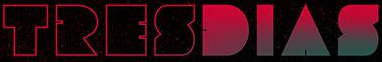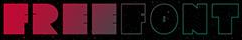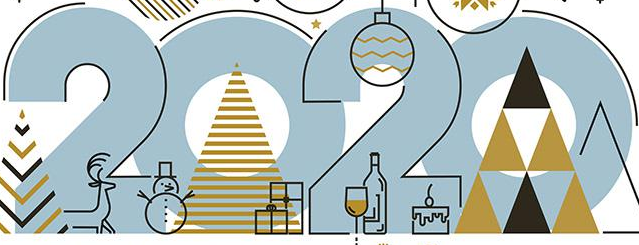Identify the words shown in these images in order, separated by a semicolon. TRESDIAS; FREEFONT; 2020 